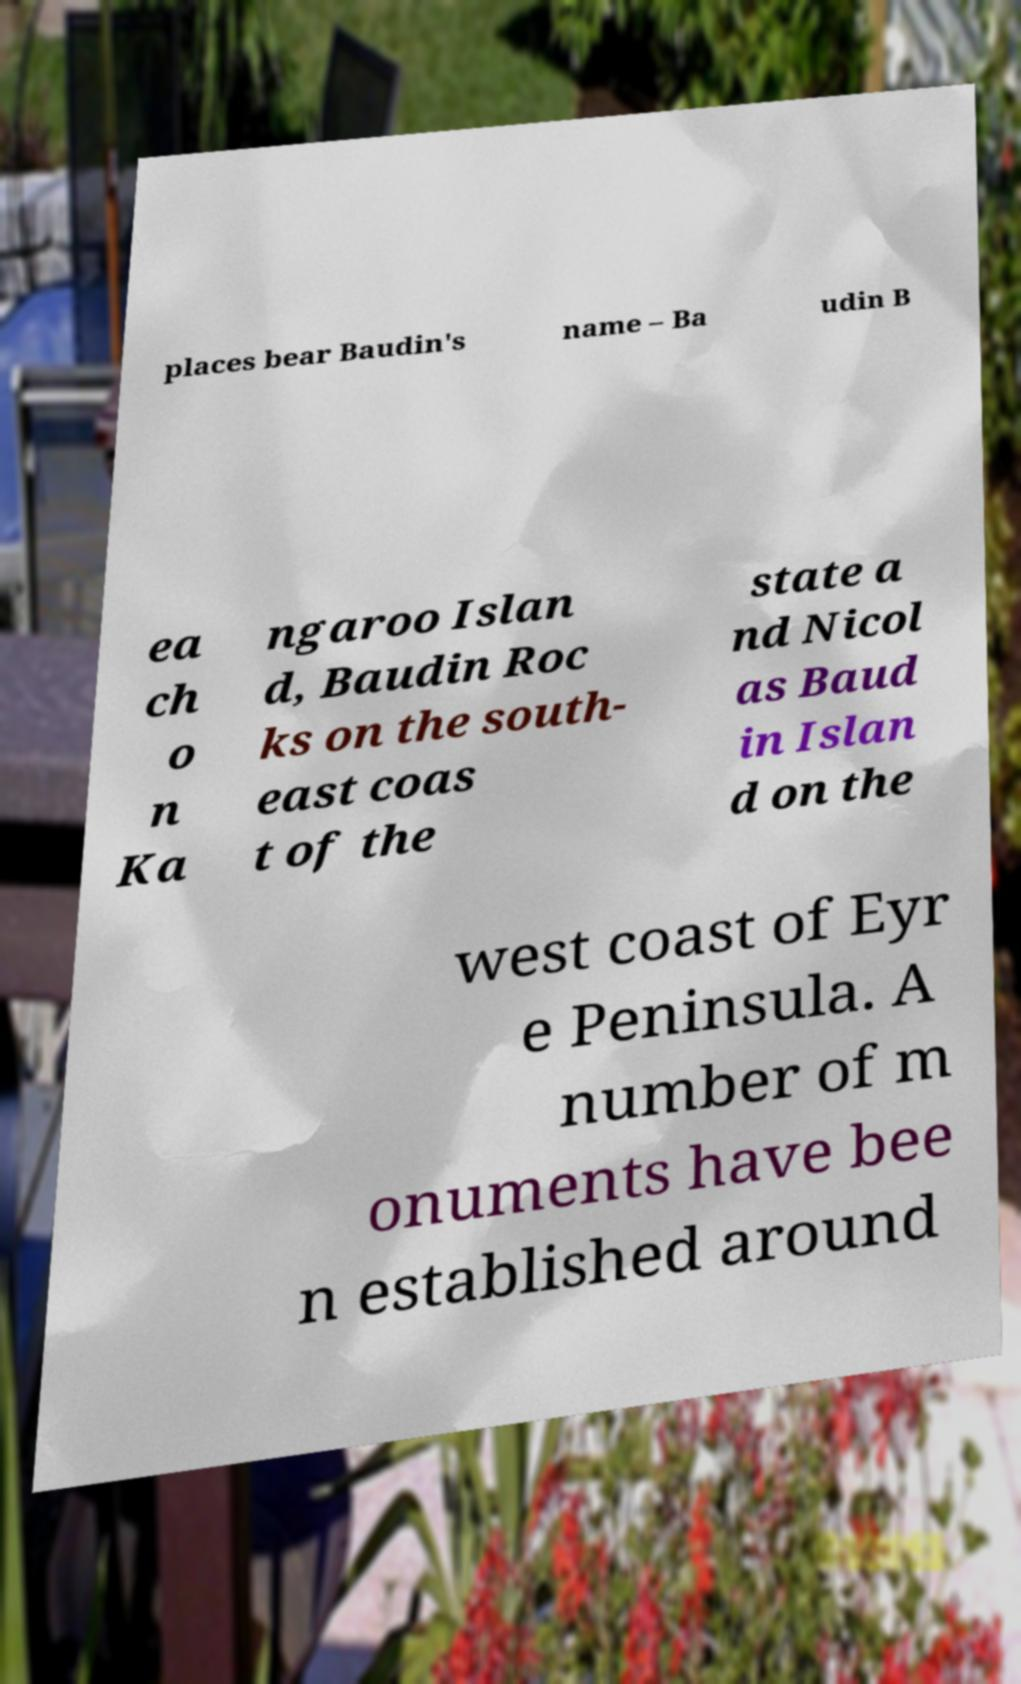For documentation purposes, I need the text within this image transcribed. Could you provide that? places bear Baudin's name – Ba udin B ea ch o n Ka ngaroo Islan d, Baudin Roc ks on the south- east coas t of the state a nd Nicol as Baud in Islan d on the west coast of Eyr e Peninsula. A number of m onuments have bee n established around 